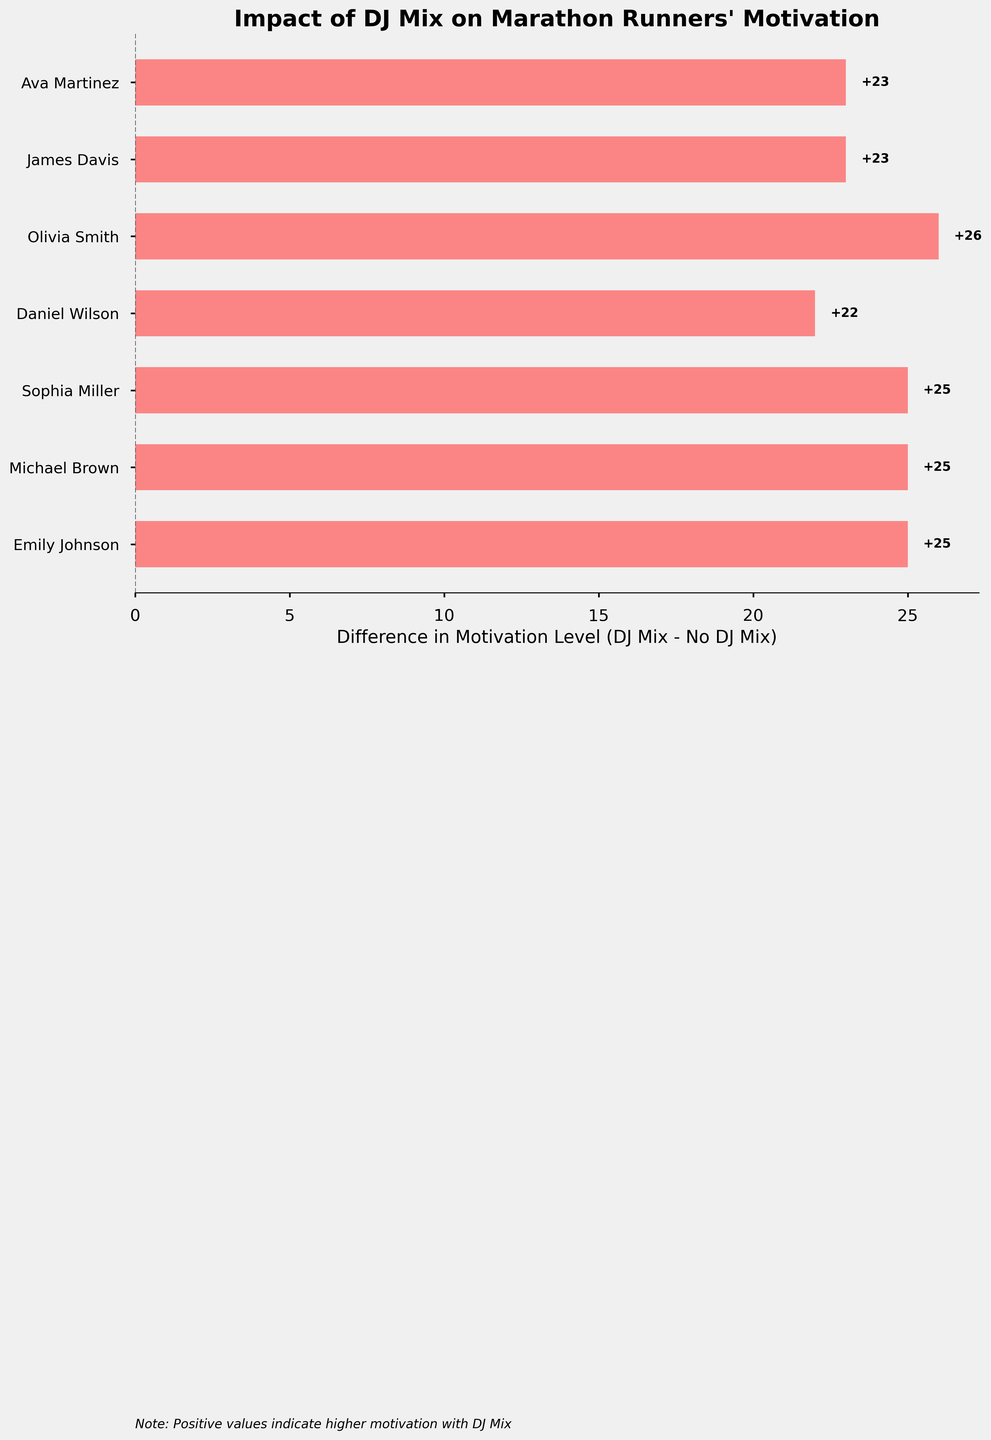What is the largest difference in motivation level between DJ Mix and No DJ Mix among the runners? The highest difference can be found by scanning all the bars to find the longest one. Daniel Wilson has the greatest difference at 22.
Answer: 22 Which runner shows the smallest difference in motivation levels with and without DJ Mix? The smallest difference is shown by Olivia Smith, as her bar is the shortest at 26 units.
Answer: Olivia Smith On average, how much does the motivation level increase with DJ Mix compared to without it? To find the average increase, sum all individual differences and divide by the number of runners: (25 + 25 + 25 + 22 + 26 + 23 + 23)/7 = 24.14.
Answer: About 24 Which runner experienced the second highest increase in motivation with DJ Mix? Observing the lengths of the bars, the second-highest increase is for Ava Martinez, with a difference of 23.
Answer: Ava Martinez How many runners experienced an increase of more than 25 points in motivation with the DJ Mix? Count the bars with values greater than 25; those are Olivia Smith, totaling 1 runner.
Answer: 1 What is the difference in motivation levels for Emily Johnson? Emily Johnson's difference is indicated by the length of her bar which is 25.
Answer: 25 Does the chart suggest that all runners experienced an increase in motivation with the DJ Mix? All bars are positive, indicating an increase.
Answer: Yes Which runner had the second smallest increase in motivation with the DJ Mix? The second smallest increase corresponds to James Davis with a difference of 23.
Answer: James Davis 